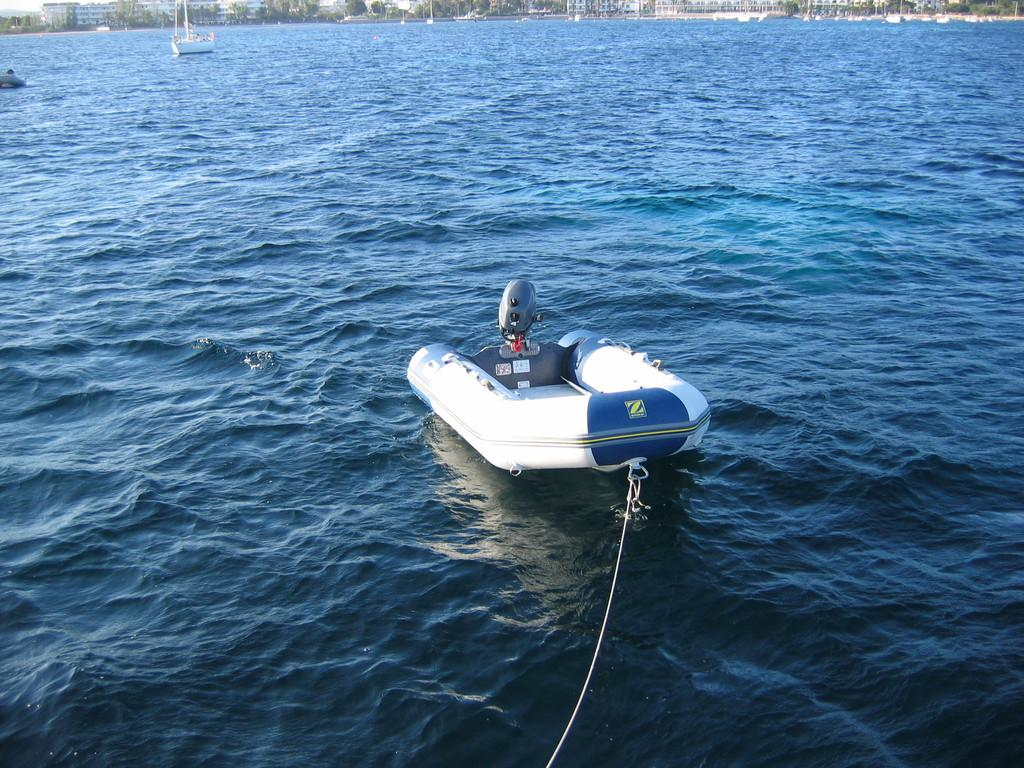<image>
Render a clear and concise summary of the photo. An inflatable boat with an outboard displays a Z logo on its bow. 